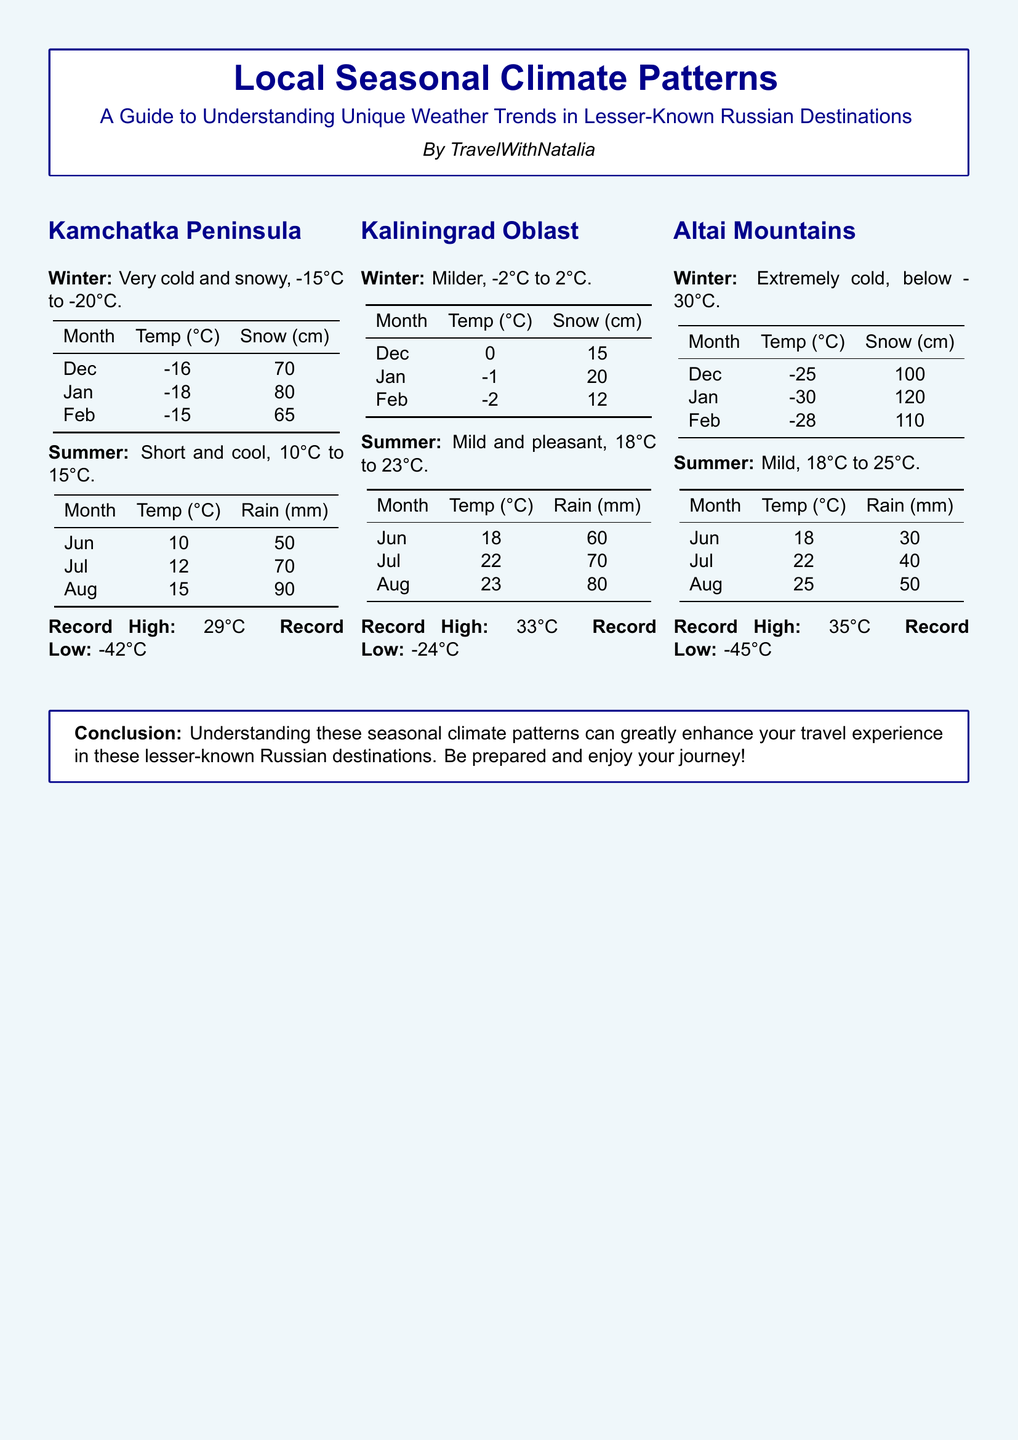What is the summer temperature range in Kamchatka Peninsula? The summer temperature range in Kamchatka Peninsula is from 10°C to 15°C.
Answer: 10°C to 15°C What is the record low temperature in Kaliningrad Oblast? The record low temperature in Kaliningrad Oblast is -24°C.
Answer: -24°C How much snow is recorded in Altai Mountains in January? The snow recorded in Altai Mountains in January is 120 cm.
Answer: 120 cm What is the average temperature in winter for Kaliningrad Oblast? The average temperature in winter for Kaliningrad Oblast is approximately -2°C to 2°C.
Answer: -2°C to 2°C Which destination has the coldest winter temperatures? The destination with the coldest winter temperatures is Altai Mountains.
Answer: Altai Mountains How much rain is recorded in August in Kamchatka Peninsula? The rainfall recorded in August in Kamchatka Peninsula is 90 mm.
Answer: 90 mm What is the summer temperature in Altai Mountains? The summer temperature in Altai Mountains ranges from 18°C to 25°C.
Answer: 18°C to 25°C What type of climate pattern does Kaliningrad Oblast experience in winter? Kaliningrad Oblast experiences a milder climate in winter.
Answer: Milder 